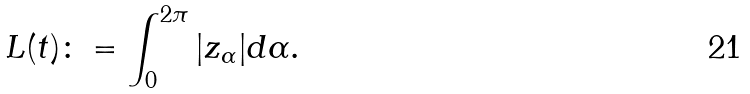Convert formula to latex. <formula><loc_0><loc_0><loc_500><loc_500>L ( t ) \colon = \int _ { 0 } ^ { 2 \pi } | z _ { \alpha } | d \alpha .</formula> 